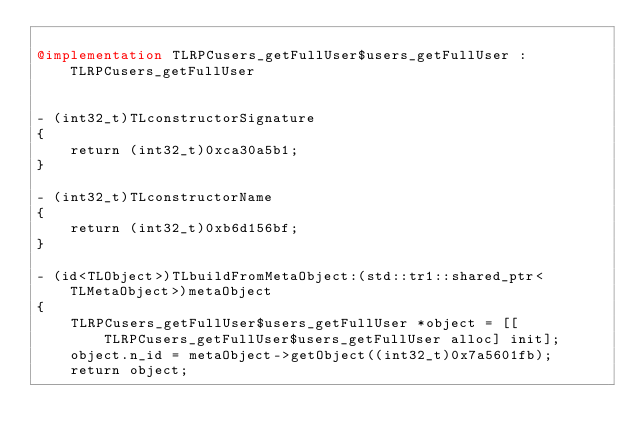Convert code to text. <code><loc_0><loc_0><loc_500><loc_500><_ObjectiveC_>
@implementation TLRPCusers_getFullUser$users_getFullUser : TLRPCusers_getFullUser


- (int32_t)TLconstructorSignature
{
    return (int32_t)0xca30a5b1;
}

- (int32_t)TLconstructorName
{
    return (int32_t)0xb6d156bf;
}

- (id<TLObject>)TLbuildFromMetaObject:(std::tr1::shared_ptr<TLMetaObject>)metaObject
{
    TLRPCusers_getFullUser$users_getFullUser *object = [[TLRPCusers_getFullUser$users_getFullUser alloc] init];
    object.n_id = metaObject->getObject((int32_t)0x7a5601fb);
    return object;</code> 